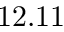<formula> <loc_0><loc_0><loc_500><loc_500>1 2 . 1 1</formula> 